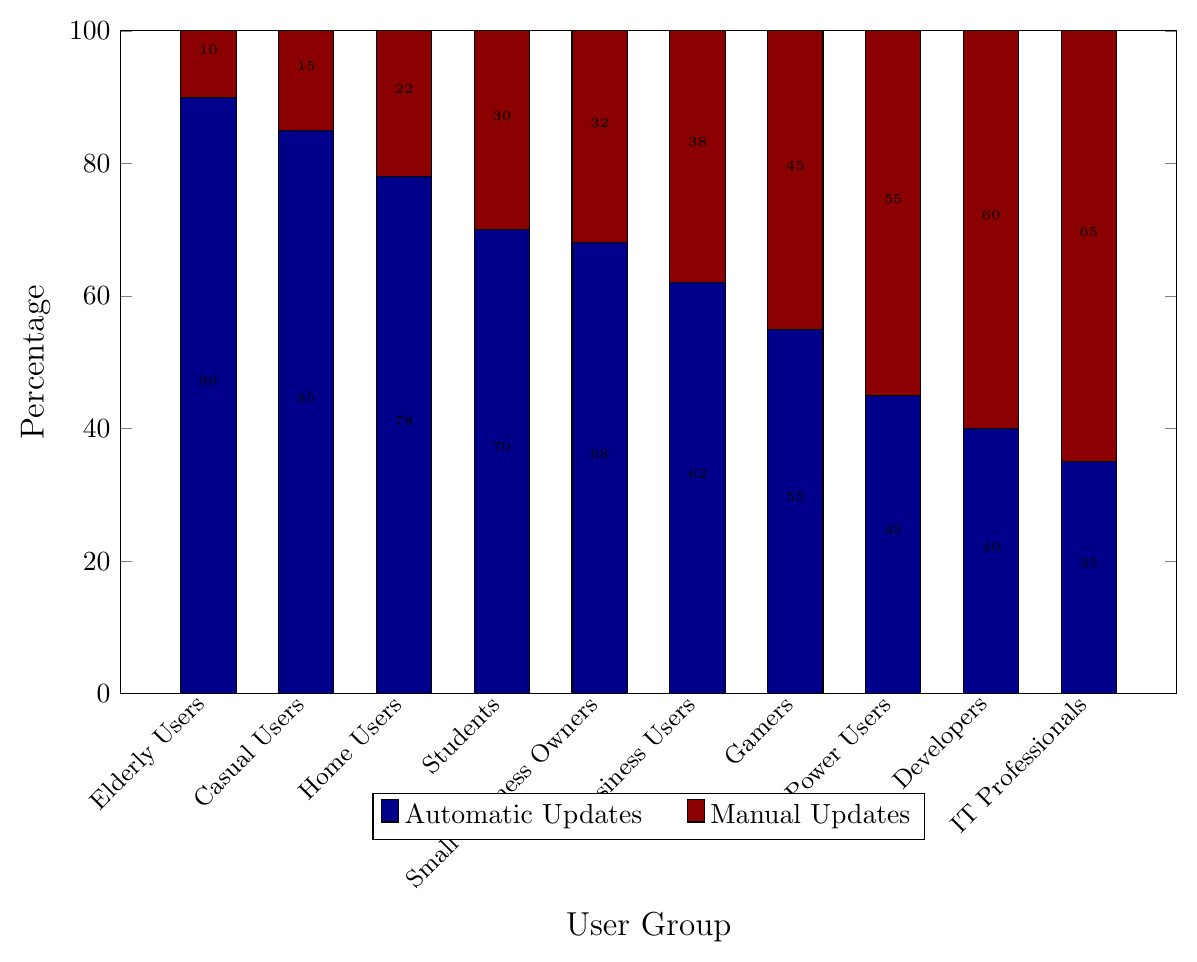Which user group has the highest percentage of automatic updates? The percentage of automatic updates per user group is shown by the dark blue bars. The highest dark blue bar appears for Elderly Users at 90%.
Answer: Elderly Users Which user group has the lowest percentage of automatic updates? The percentage of automatic updates per user group is shown by the dark blue bars. The lowest dark blue bar appears for IT Professionals at 35%.
Answer: IT Professionals Which two user groups have the closest percentage values for manual updates? The percentage of manual updates per user group is shown by the dark red bars. Developers and IT Professionals have manual update percentages of 60% and 65%, respectively, which are the closest among all groups.
Answer: Developers and IT Professionals What’s the average percentage of automatic updates for Home Users, Business Users, and Power Users? The percentages of automatic updates are 78% for Home Users, 62% for Business Users, and 45% for Power Users. (78 + 62 + 45) / 3 = 185 / 3 = 61.67%
Answer: 61.67% How much higher is the percentage of automatic updates for Elderly Users compared to Gamers? Elderly Users have 90% automatic updates and Gamers have 55%. The difference is 90% - 55% = 35%.
Answer: 35% Which user group has a higher percentage of manual updates, Gamers or Students? The percentage of manual updates for Gamers is 45%, and for Students, it is 30%. Comparing the two, Gamers have a higher percentage.
Answer: Gamers What is the combined percentage of automatic and manual updates for Small Business Owners? The chart indicates that Small Business Owners have 68% automatic updates and 32% manual updates. Adding these gives 68% + 32% = 100%.
Answer: 100% Which has a greater difference between the percentages of automatic and manual updates: Home Users or Students? For Home Users, Automatic vs. Manual is 78% vs. 22%; the difference is 78% - 22% = 56%. For Students, Automatic vs. Manual is 70% vs. 30%; the difference is 70% - 30% = 40%. Therefore, the difference is greater for Home Users.
Answer: Home Users Between Casual Users and Developers, who has a higher percentage of automatic updates, and by how much? Casual Users have 85% automatic updates, while Developers have 40%. The difference is 85% - 40% = 45%.
Answer: Casual Users by 45% Which group has the most balanced distribution between automatic and manual updates? A balanced distribution would be where the percentages of automatic and manual updates are close. Power Users have 45% automatic and 55% manual updates, which is the closest to a 50-50 split.
Answer: Power Users 